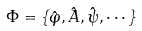<formula> <loc_0><loc_0><loc_500><loc_500>\Phi = \{ \hat { \varphi } , \hat { A } , \hat { \psi } , \cdots \}</formula> 